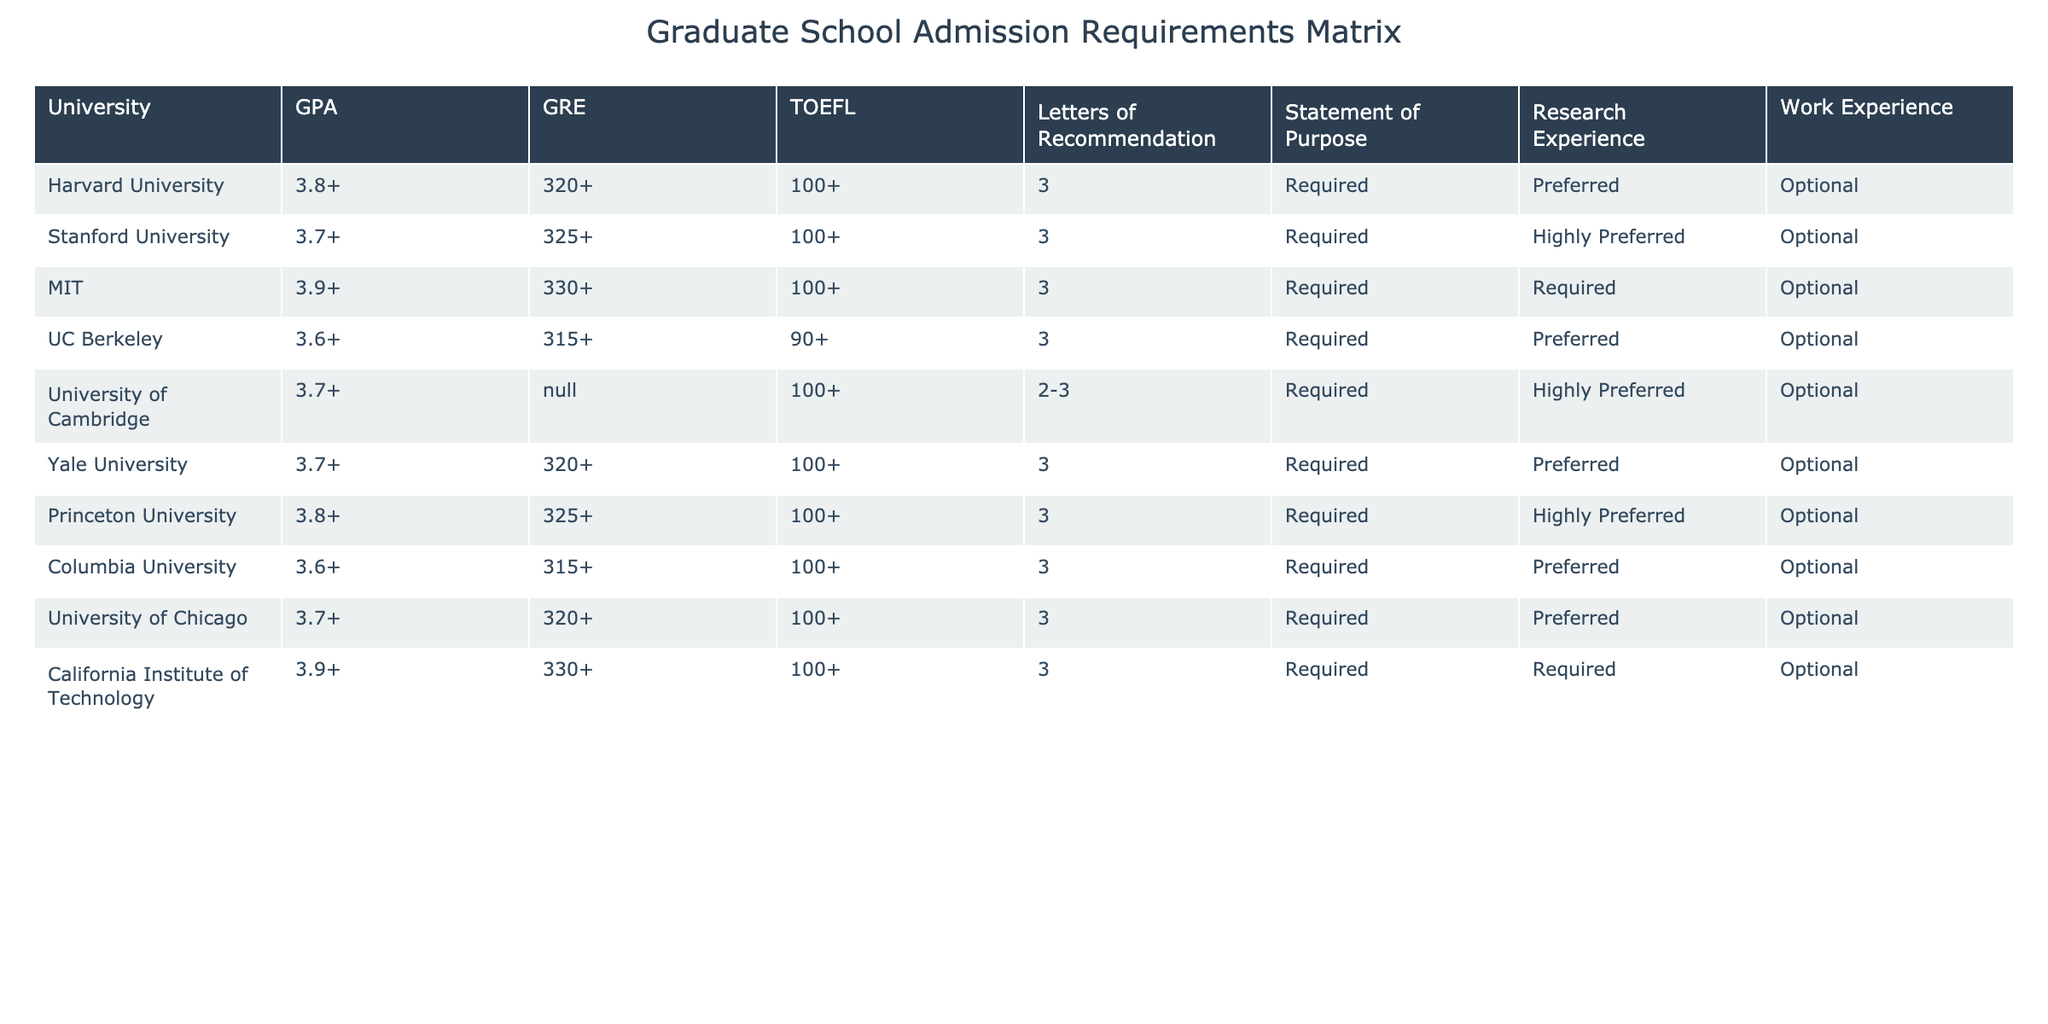What is the minimum GPA requirement for MIT? From the table, MIT has a GPA requirement of 3.9 or higher.
Answer: 3.9+ Which university has the highest GRE score requirement? By reviewing the GRE scores, both MIT and California Institute of Technology require a GRE score of 330 or higher, which is the highest among the listed universities.
Answer: MIT and California Institute of Technology Is research experience required for all universities? By checking the table, it shows that research experience is labeled as "Required" for some universities like MIT and California Institute of Technology, and "Preferred" or "Optional" for others, indicating that it is not required for all.
Answer: No How many universities require 3 letters of recommendation? The table indicates that 8 out of the 10 universities listed require 3 letters of recommendation.
Answer: 8 Which university has the lowest TOEFL score requirement? According to the table, UC Berkeley has the lowest TOEFL score requirement of 90 or higher.
Answer: UC Berkeley Are there any universities that do not list a GRE score requirement? The table indicates that the University of Cambridge has "N/A" listed for GRE scores, meaning it does not require a GRE score.
Answer: Yes What is the average GPA requirement for the listed universities? The GPA requirements are 3.8, 3.7, 3.9, 3.6, 3.7, 3.7, 3.8, 3.6, 3.7, and 3.9. Adding these values gives 37.6, and dividing by 10 results in an average of 3.76.
Answer: 3.76 Which universities require a Statement of Purpose? The table indicates that all the universities listed require a Statement of Purpose.
Answer: All universities Which university has a higher GRE requirement: Princeton University or Yale University? By comparing their GRE scores, Princeton University requires 325 or higher, while Yale University requires 320 or higher, indicating that Princeton University has a higher requirement.
Answer: Princeton University What are the commonalities in work experience requirement among the listed universities? The table shows that work experience is labeled as "Optional" for all universities, indicating a commonality in that no university requires it.
Answer: Optional for all 